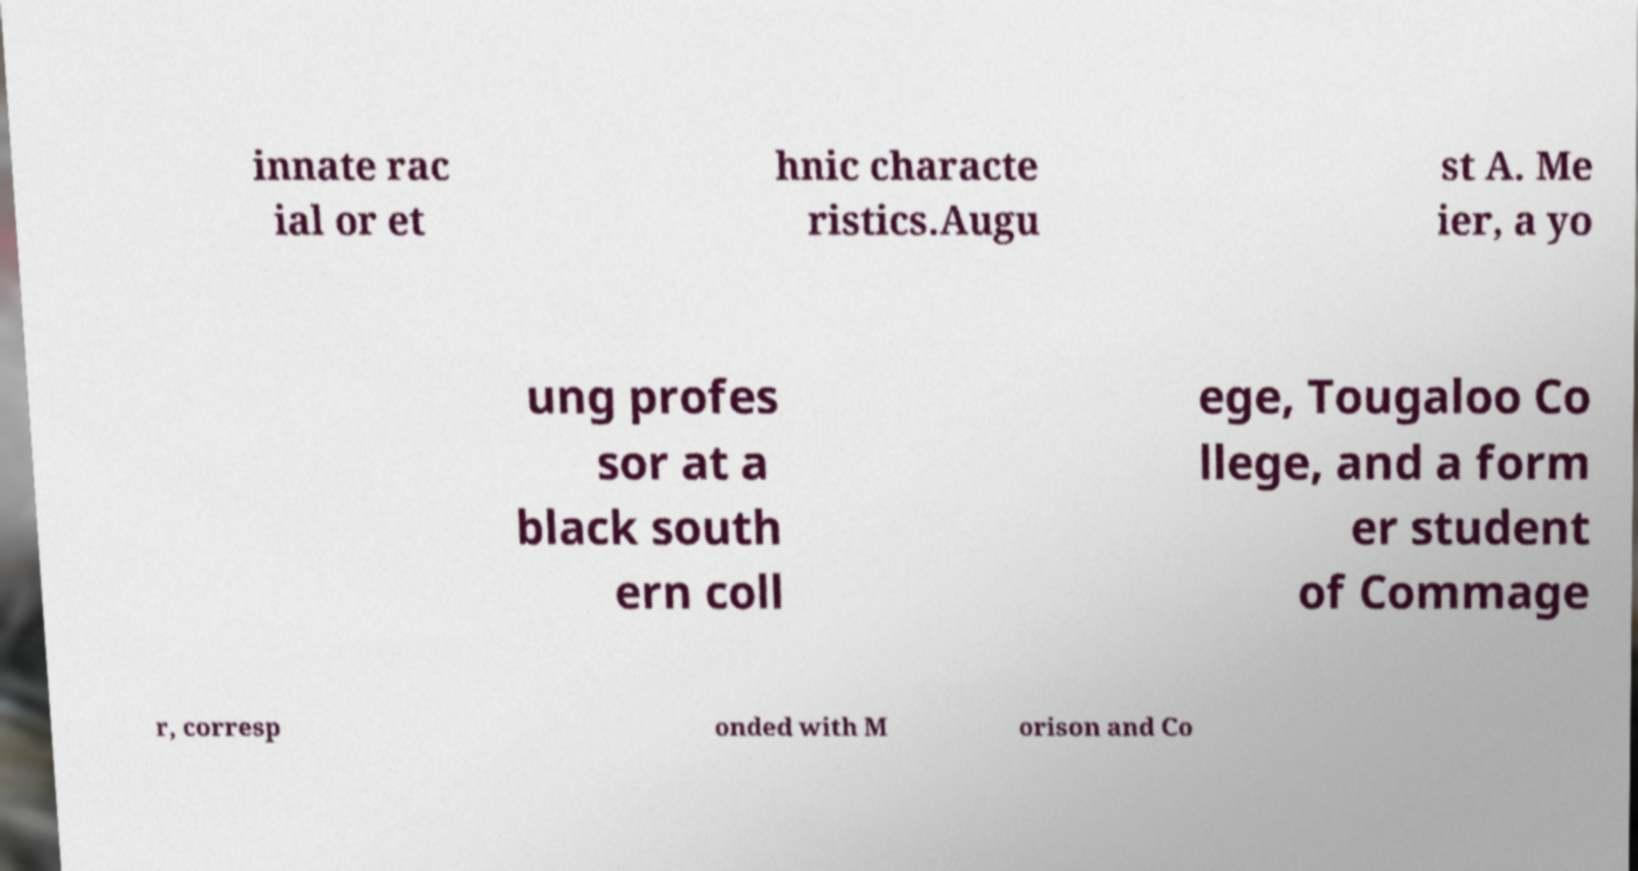What messages or text are displayed in this image? I need them in a readable, typed format. innate rac ial or et hnic characte ristics.Augu st A. Me ier, a yo ung profes sor at a black south ern coll ege, Tougaloo Co llege, and a form er student of Commage r, corresp onded with M orison and Co 